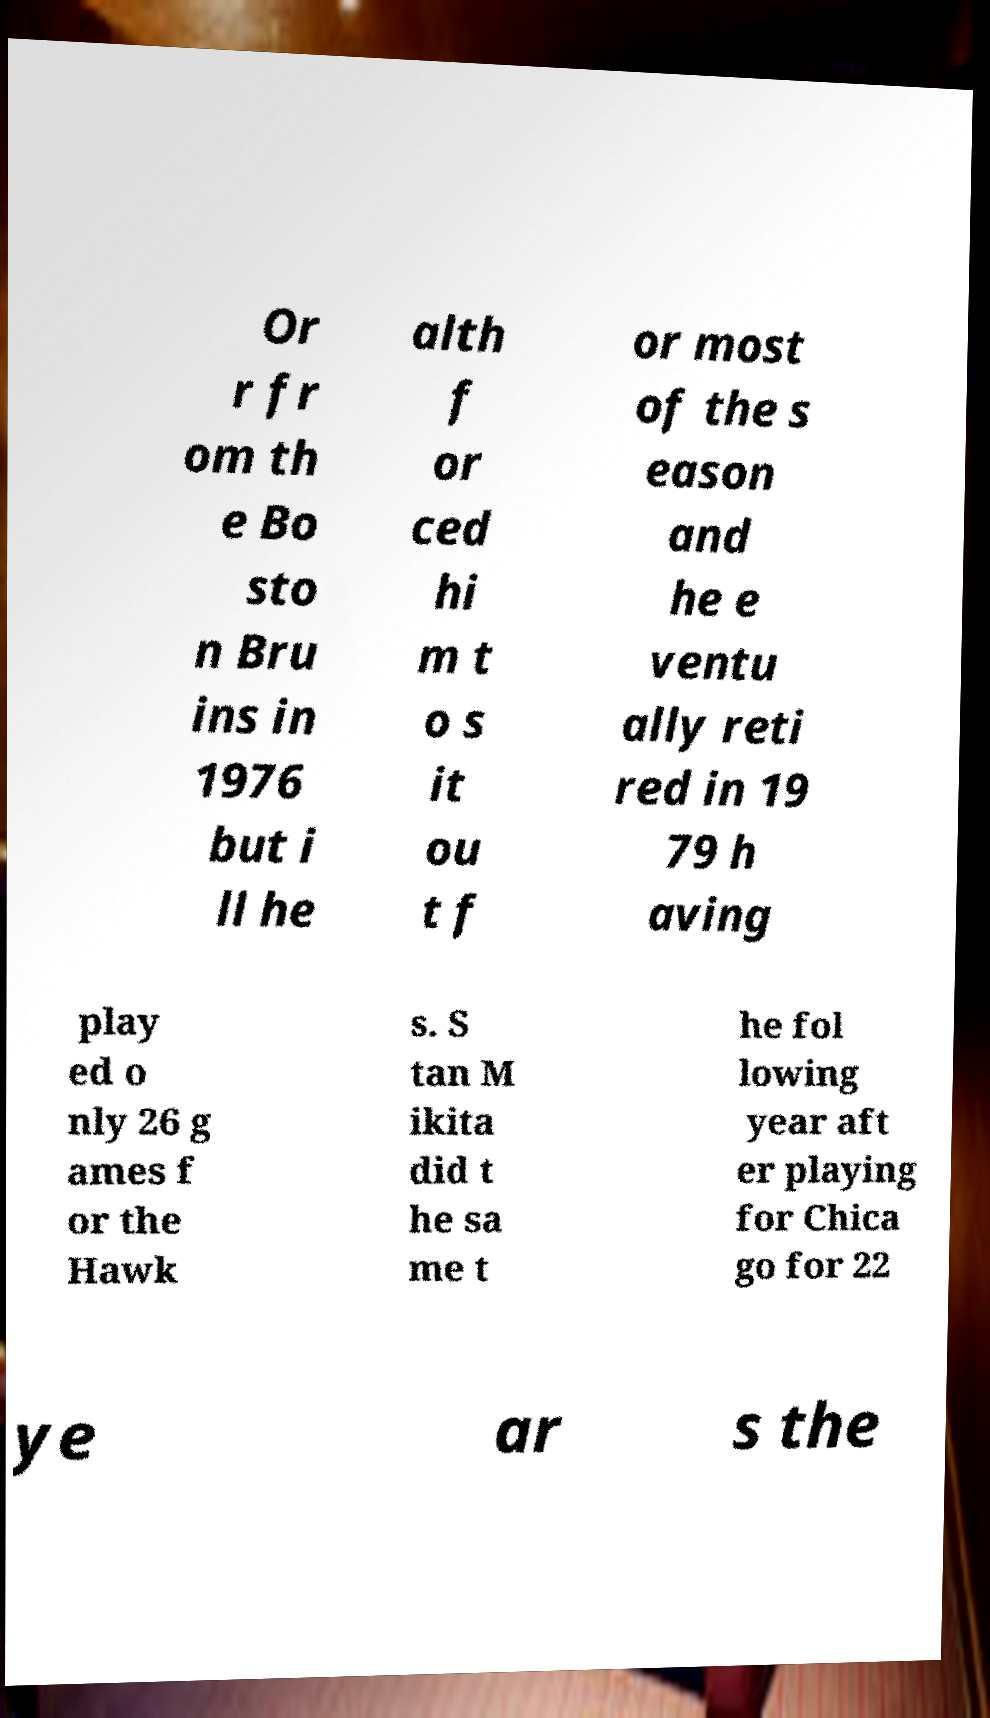Could you assist in decoding the text presented in this image and type it out clearly? Or r fr om th e Bo sto n Bru ins in 1976 but i ll he alth f or ced hi m t o s it ou t f or most of the s eason and he e ventu ally reti red in 19 79 h aving play ed o nly 26 g ames f or the Hawk s. S tan M ikita did t he sa me t he fol lowing year aft er playing for Chica go for 22 ye ar s the 